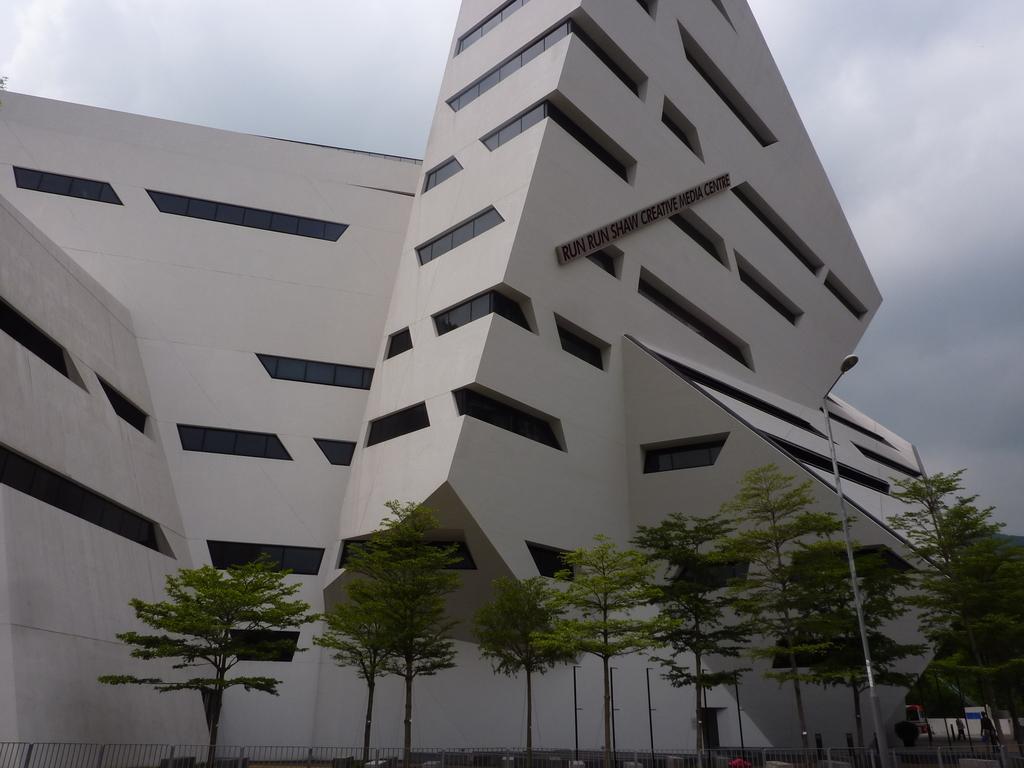In one or two sentences, can you explain what this image depicts? In this image there is a building, in front of the building there are trees, railing, pole and streetlight. 